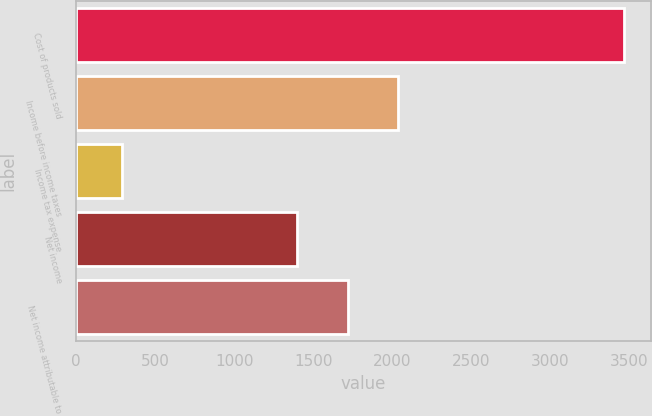<chart> <loc_0><loc_0><loc_500><loc_500><bar_chart><fcel>Cost of products sold<fcel>Income before income taxes<fcel>Income tax expense<fcel>Net income<fcel>Net income attributable to<nl><fcel>3466<fcel>2035.6<fcel>293<fcel>1401<fcel>1718.3<nl></chart> 